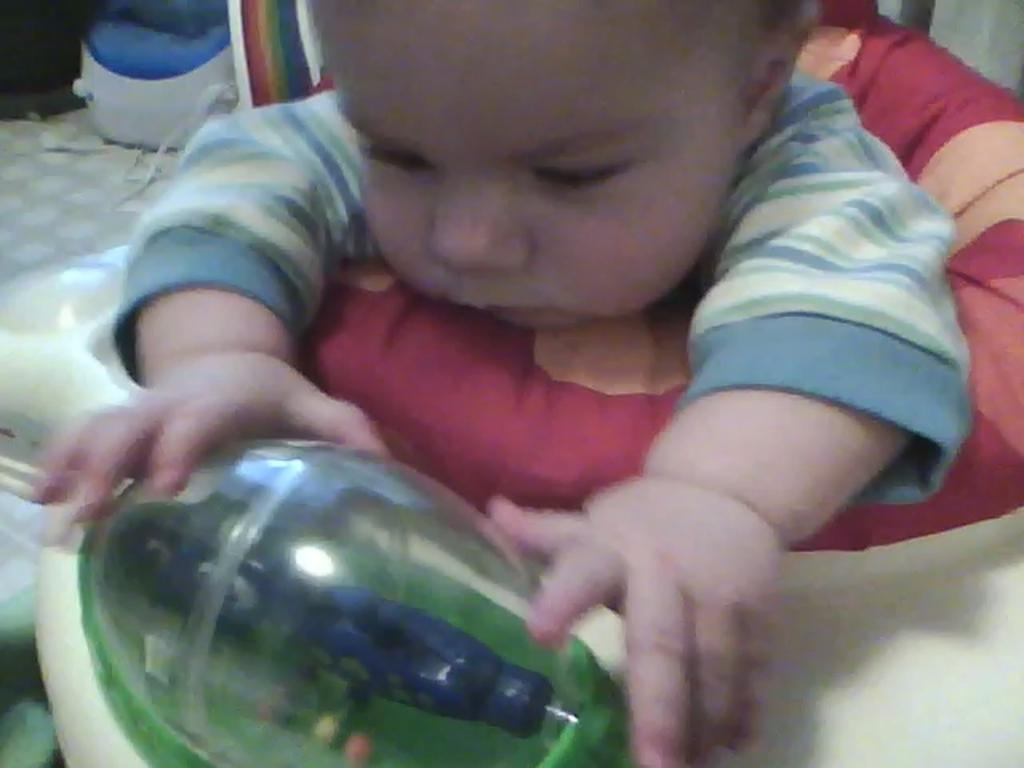What is the main subject of the image? There is a baby in the image. How is the baby positioned in the image? The baby is sitting in a walker. What other object can be seen on the floor in the image? There is a leg massager on the floor in the image. Is the baby driving a car in the image? No, the baby is not driving a car in the image; they are sitting in a walker. Can you tell me how many drawers are visible in the image? There are no drawers present in the image. 